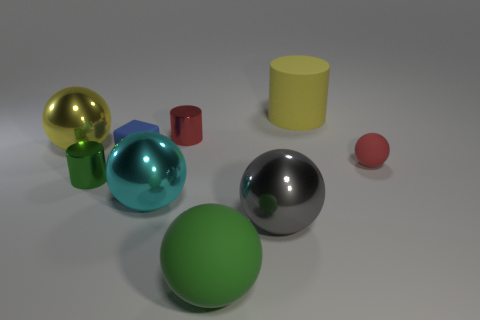Is the cyan thing the same shape as the big green thing?
Your answer should be compact. Yes. There is a ball that is in front of the large gray metallic sphere; is it the same size as the ball to the left of the cube?
Offer a terse response. Yes. How many things are either tiny blue blocks that are in front of the large yellow cylinder or small purple metal cylinders?
Offer a very short reply. 1. What is the material of the yellow ball?
Offer a terse response. Metal. Is the gray thing the same size as the cyan thing?
Make the answer very short. Yes. How many balls are small red metallic things or cyan things?
Offer a terse response. 1. There is a tiny shiny thing that is behind the tiny blue object that is behind the red sphere; what color is it?
Offer a very short reply. Red. Are there fewer small red matte objects that are behind the gray object than large spheres in front of the red matte object?
Offer a terse response. Yes. Do the green cylinder and the yellow object on the right side of the rubber block have the same size?
Ensure brevity in your answer.  No. There is a matte object that is right of the large green object and to the left of the small red rubber ball; what shape is it?
Ensure brevity in your answer.  Cylinder. 